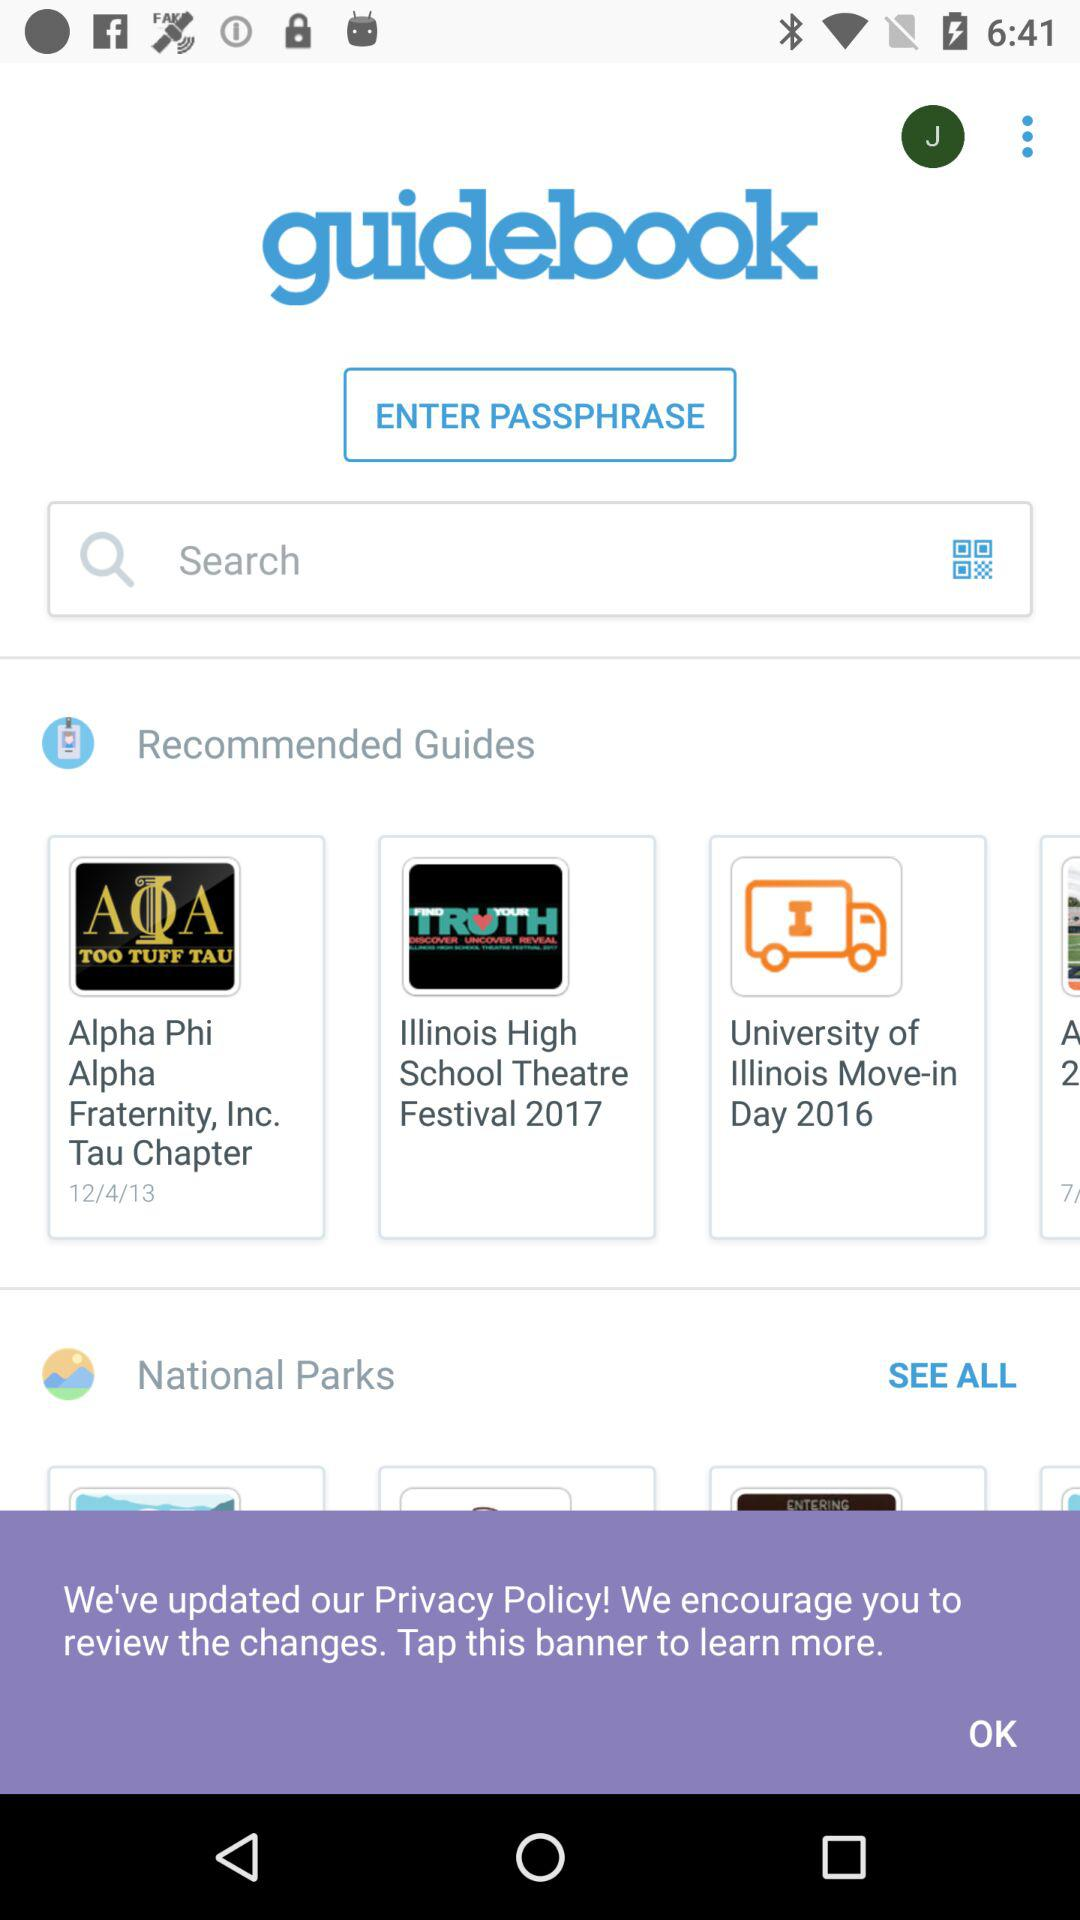How many recommended guides are there?
Answer the question using a single word or phrase. 4 